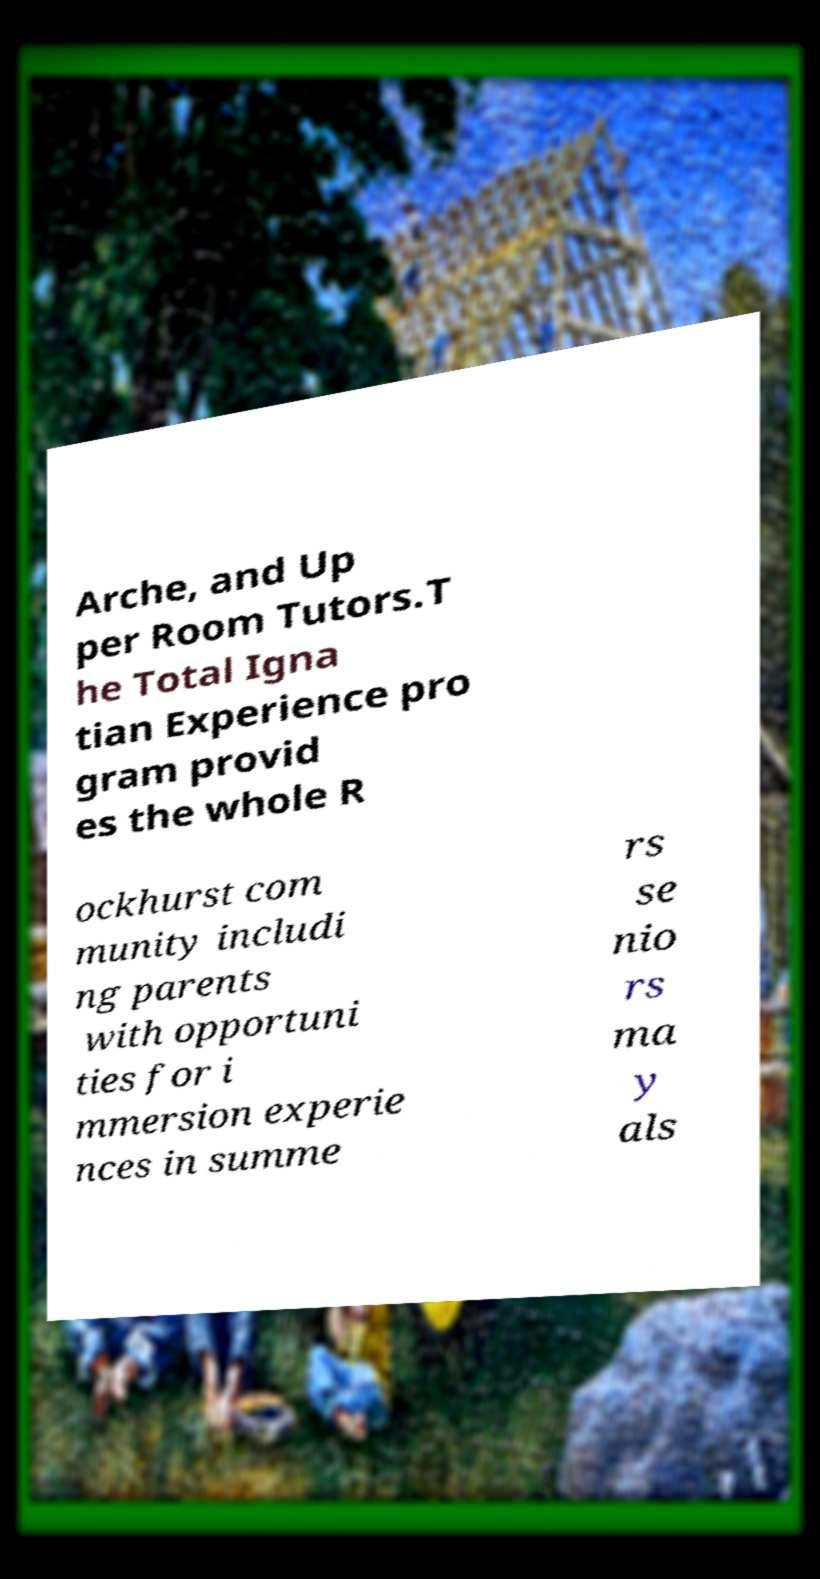I need the written content from this picture converted into text. Can you do that? Arche, and Up per Room Tutors.T he Total Igna tian Experience pro gram provid es the whole R ockhurst com munity includi ng parents with opportuni ties for i mmersion experie nces in summe rs se nio rs ma y als 